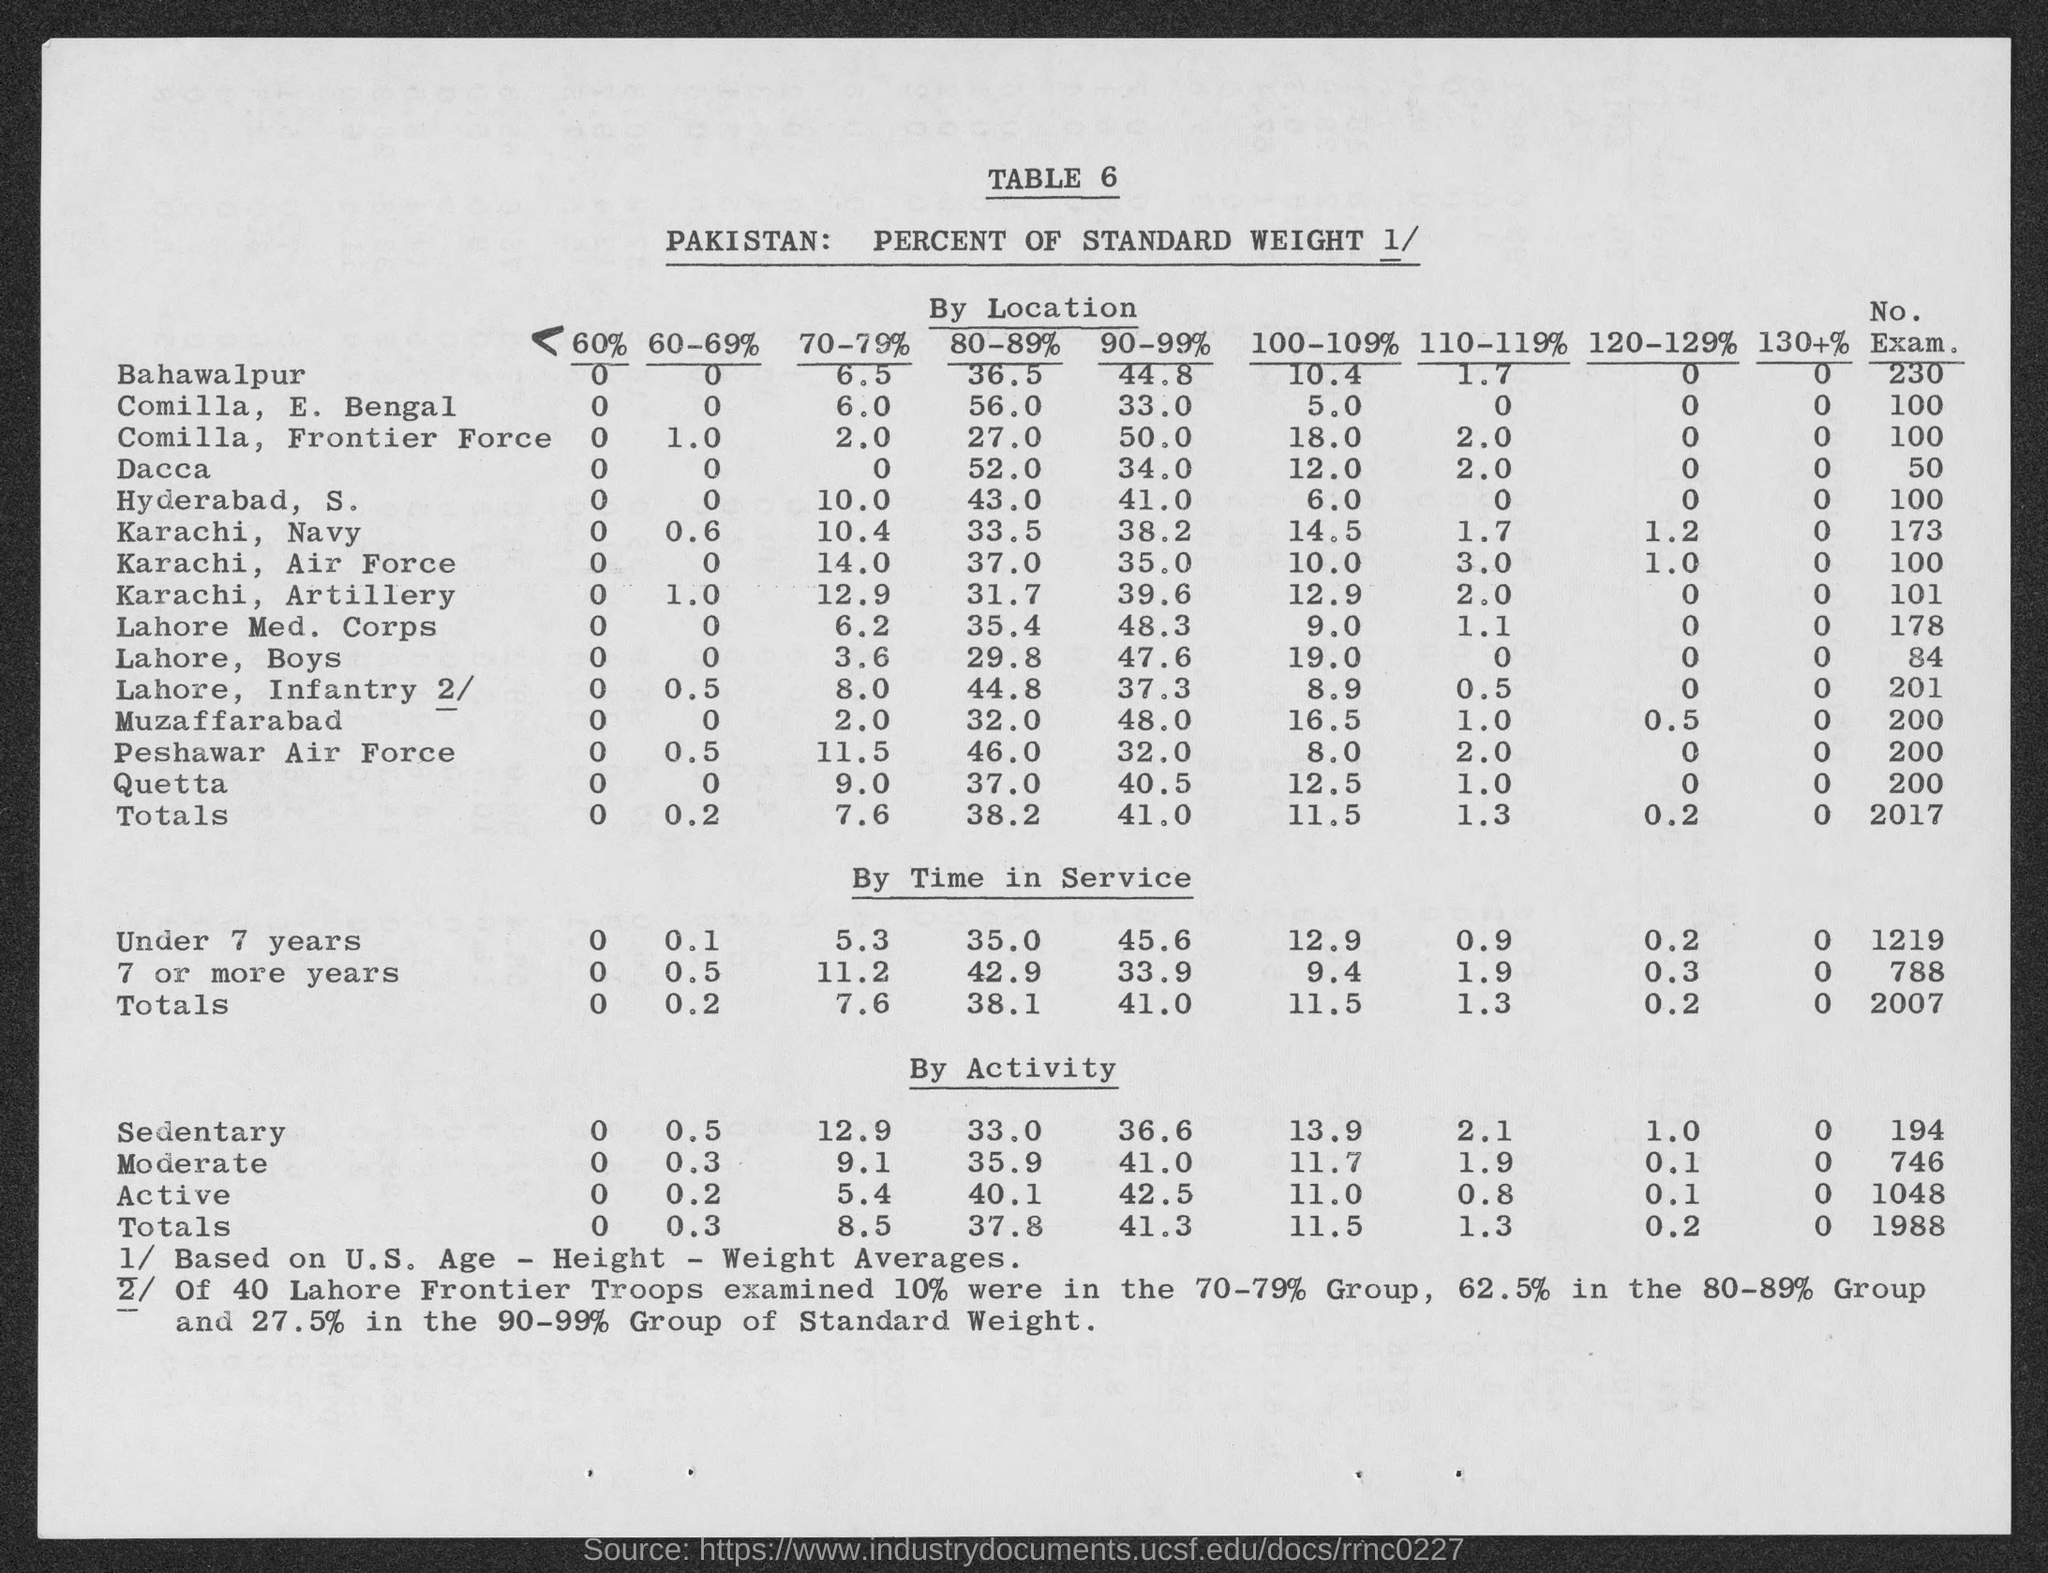Point out several critical features in this image. The total for 120-129% is 0.2. The total for 60% is X, and the values range from 0 to Y. The total for scores in the range of 80-89% in "By Location" is 38.2. The total for scores within the range of 90-99% in the "By Location" category is 41.0. The total for 70-79% in the "By Location" category is 7.6. 